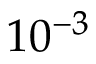<formula> <loc_0><loc_0><loc_500><loc_500>1 0 ^ { - 3 }</formula> 